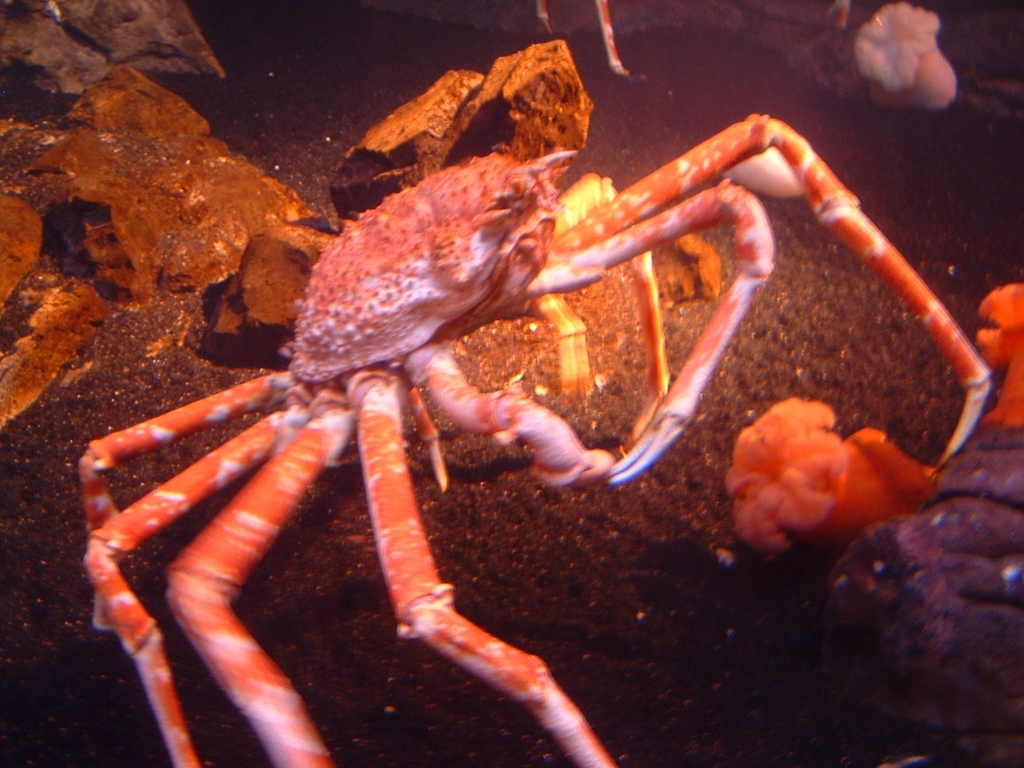What is the overall sharpness like in the image? Upon examination, the image depicts a crab with a noticeable lack of crispness, particularly around its limbs and the surrounding environment, possibly due to the underwater setting and the lighting conditions. However, a definitive judgment on the sharpness quality cannot be provided without considering factors such as the original intent of the photographer, the equipment used, or knowing if the image has been altered post-capture. Based on the visible assessment, though, it seems that the sharpness falls below what would typically be considered high or excellent, and might be closer to average or slightly below average due to the perceived blurriness. 